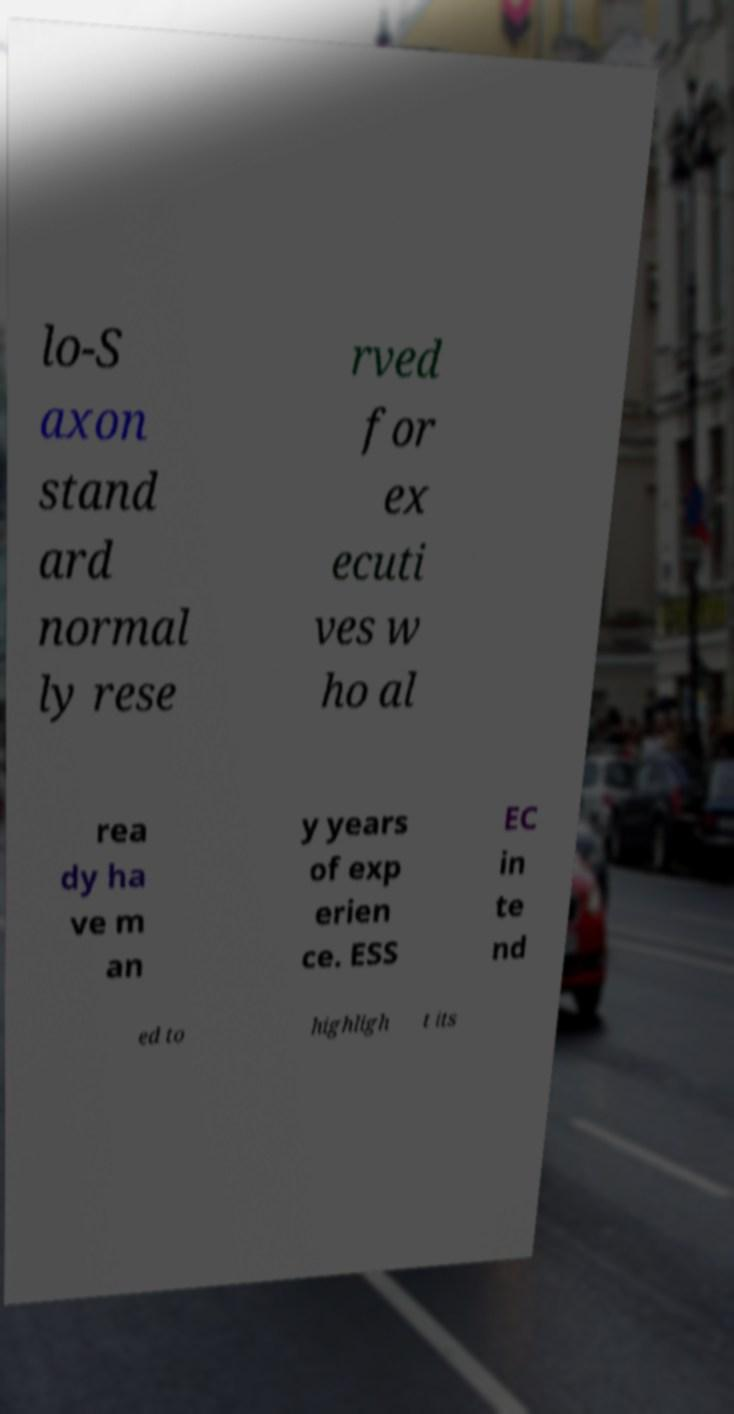Can you read and provide the text displayed in the image?This photo seems to have some interesting text. Can you extract and type it out for me? lo-S axon stand ard normal ly rese rved for ex ecuti ves w ho al rea dy ha ve m an y years of exp erien ce. ESS EC in te nd ed to highligh t its 